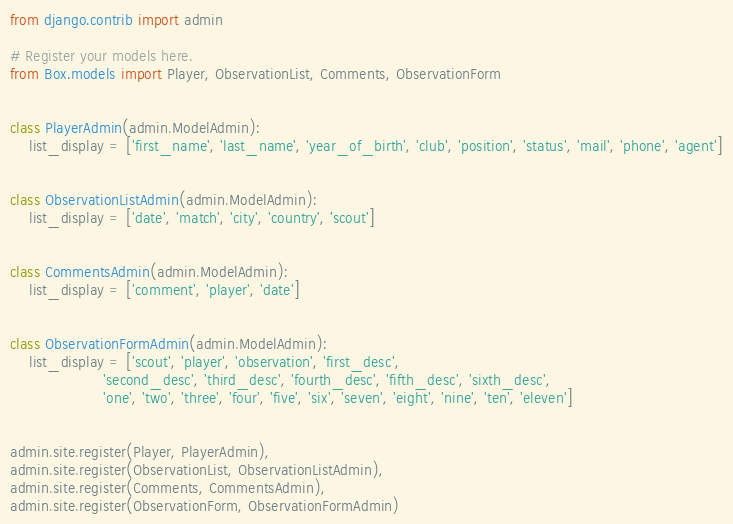<code> <loc_0><loc_0><loc_500><loc_500><_Python_>from django.contrib import admin

# Register your models here.
from Box.models import Player, ObservationList, Comments, ObservationForm


class PlayerAdmin(admin.ModelAdmin):
    list_display = ['first_name', 'last_name', 'year_of_birth', 'club', 'position', 'status', 'mail', 'phone', 'agent']


class ObservationListAdmin(admin.ModelAdmin):
    list_display = ['date', 'match', 'city', 'country', 'scout']


class CommentsAdmin(admin.ModelAdmin):
    list_display = ['comment', 'player', 'date']


class ObservationFormAdmin(admin.ModelAdmin):
    list_display = ['scout', 'player', 'observation', 'first_desc',
                    'second_desc', 'third_desc', 'fourth_desc', 'fifth_desc', 'sixth_desc',
                    'one', 'two', 'three', 'four', 'five', 'six', 'seven', 'eight', 'nine', 'ten', 'eleven']


admin.site.register(Player, PlayerAdmin),
admin.site.register(ObservationList, ObservationListAdmin),
admin.site.register(Comments, CommentsAdmin),
admin.site.register(ObservationForm, ObservationFormAdmin)</code> 